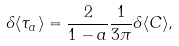<formula> <loc_0><loc_0><loc_500><loc_500>\delta \langle \tau _ { a } \rangle = \frac { 2 } { 1 - a } \frac { 1 } { 3 \pi } \delta \langle C \rangle ,</formula> 